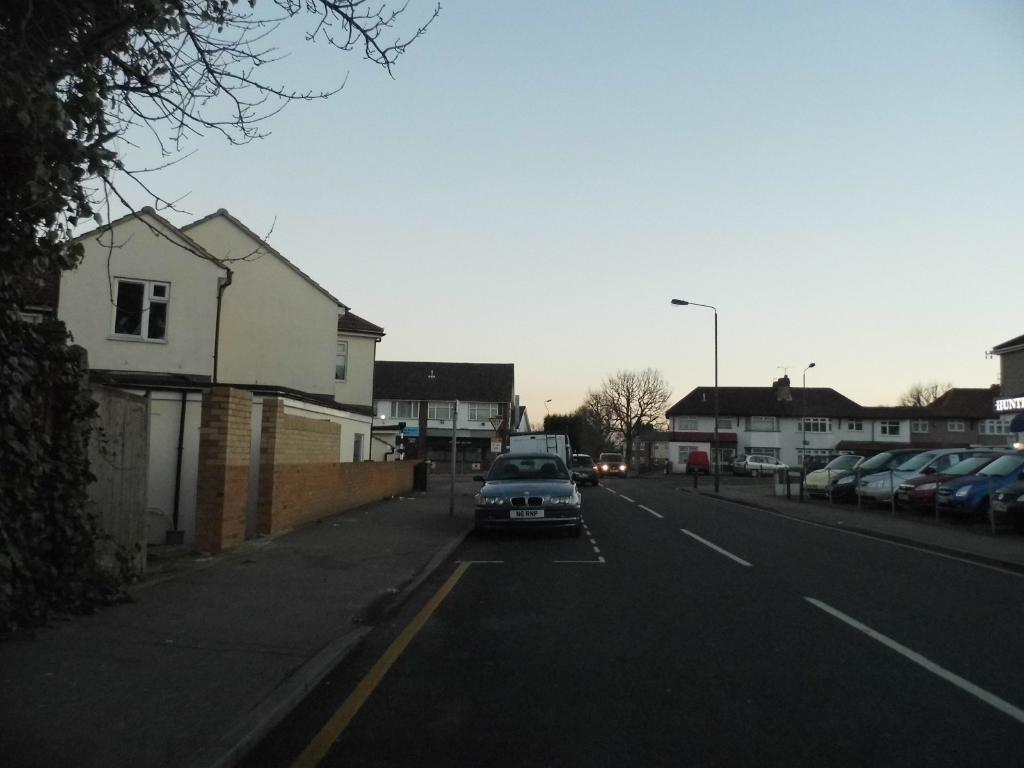What type of objects can be seen in the foreground of the image? There are vehicles in the image. What structures are visible behind the vehicles? There are buildings visible behind the vehicles. What type of natural elements can be seen in the background of the image? Trees are present in the background of the image. What type of man-made structures are present in the background of the image? There are poles with lights in the background of the image. What is visible at the top of the image? The sky is visible at the top of the image. What color is the tramp's skirt in the image? There is no tramp or skirt present in the image. How does the stomach of the person driving the vehicle feel in the image? There is no information about the feelings or physical sensations of the people in the image. 